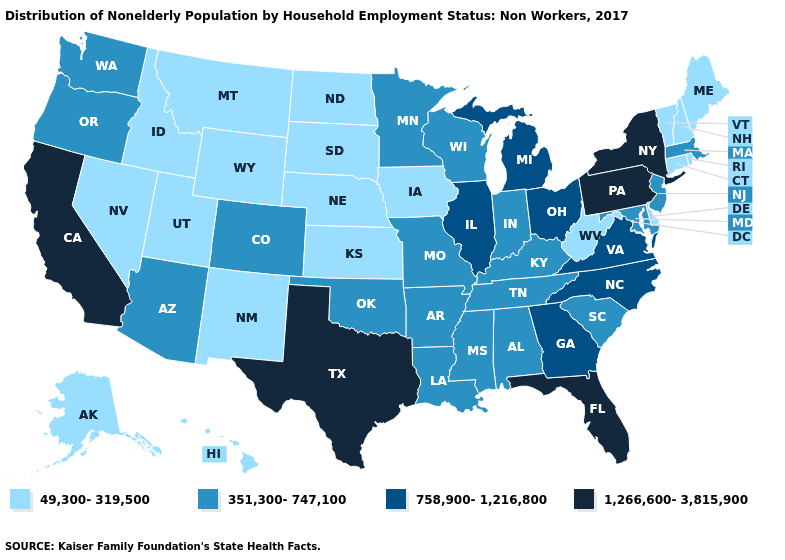Name the states that have a value in the range 49,300-319,500?
Be succinct. Alaska, Connecticut, Delaware, Hawaii, Idaho, Iowa, Kansas, Maine, Montana, Nebraska, Nevada, New Hampshire, New Mexico, North Dakota, Rhode Island, South Dakota, Utah, Vermont, West Virginia, Wyoming. Which states have the lowest value in the USA?
Keep it brief. Alaska, Connecticut, Delaware, Hawaii, Idaho, Iowa, Kansas, Maine, Montana, Nebraska, Nevada, New Hampshire, New Mexico, North Dakota, Rhode Island, South Dakota, Utah, Vermont, West Virginia, Wyoming. Name the states that have a value in the range 49,300-319,500?
Write a very short answer. Alaska, Connecticut, Delaware, Hawaii, Idaho, Iowa, Kansas, Maine, Montana, Nebraska, Nevada, New Hampshire, New Mexico, North Dakota, Rhode Island, South Dakota, Utah, Vermont, West Virginia, Wyoming. How many symbols are there in the legend?
Concise answer only. 4. Which states hav the highest value in the Northeast?
Be succinct. New York, Pennsylvania. Does the map have missing data?
Concise answer only. No. Name the states that have a value in the range 351,300-747,100?
Concise answer only. Alabama, Arizona, Arkansas, Colorado, Indiana, Kentucky, Louisiana, Maryland, Massachusetts, Minnesota, Mississippi, Missouri, New Jersey, Oklahoma, Oregon, South Carolina, Tennessee, Washington, Wisconsin. What is the value of Oregon?
Be succinct. 351,300-747,100. How many symbols are there in the legend?
Concise answer only. 4. What is the value of Rhode Island?
Give a very brief answer. 49,300-319,500. What is the value of California?
Give a very brief answer. 1,266,600-3,815,900. What is the highest value in the USA?
Answer briefly. 1,266,600-3,815,900. What is the highest value in the USA?
Concise answer only. 1,266,600-3,815,900. What is the value of Wisconsin?
Concise answer only. 351,300-747,100. What is the highest value in the USA?
Give a very brief answer. 1,266,600-3,815,900. 